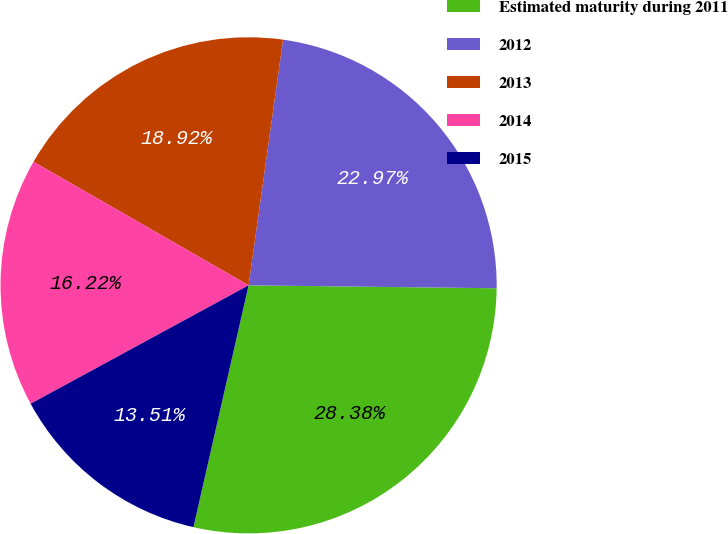Convert chart to OTSL. <chart><loc_0><loc_0><loc_500><loc_500><pie_chart><fcel>Estimated maturity during 2011<fcel>2012<fcel>2013<fcel>2014<fcel>2015<nl><fcel>28.38%<fcel>22.97%<fcel>18.92%<fcel>16.22%<fcel>13.51%<nl></chart> 